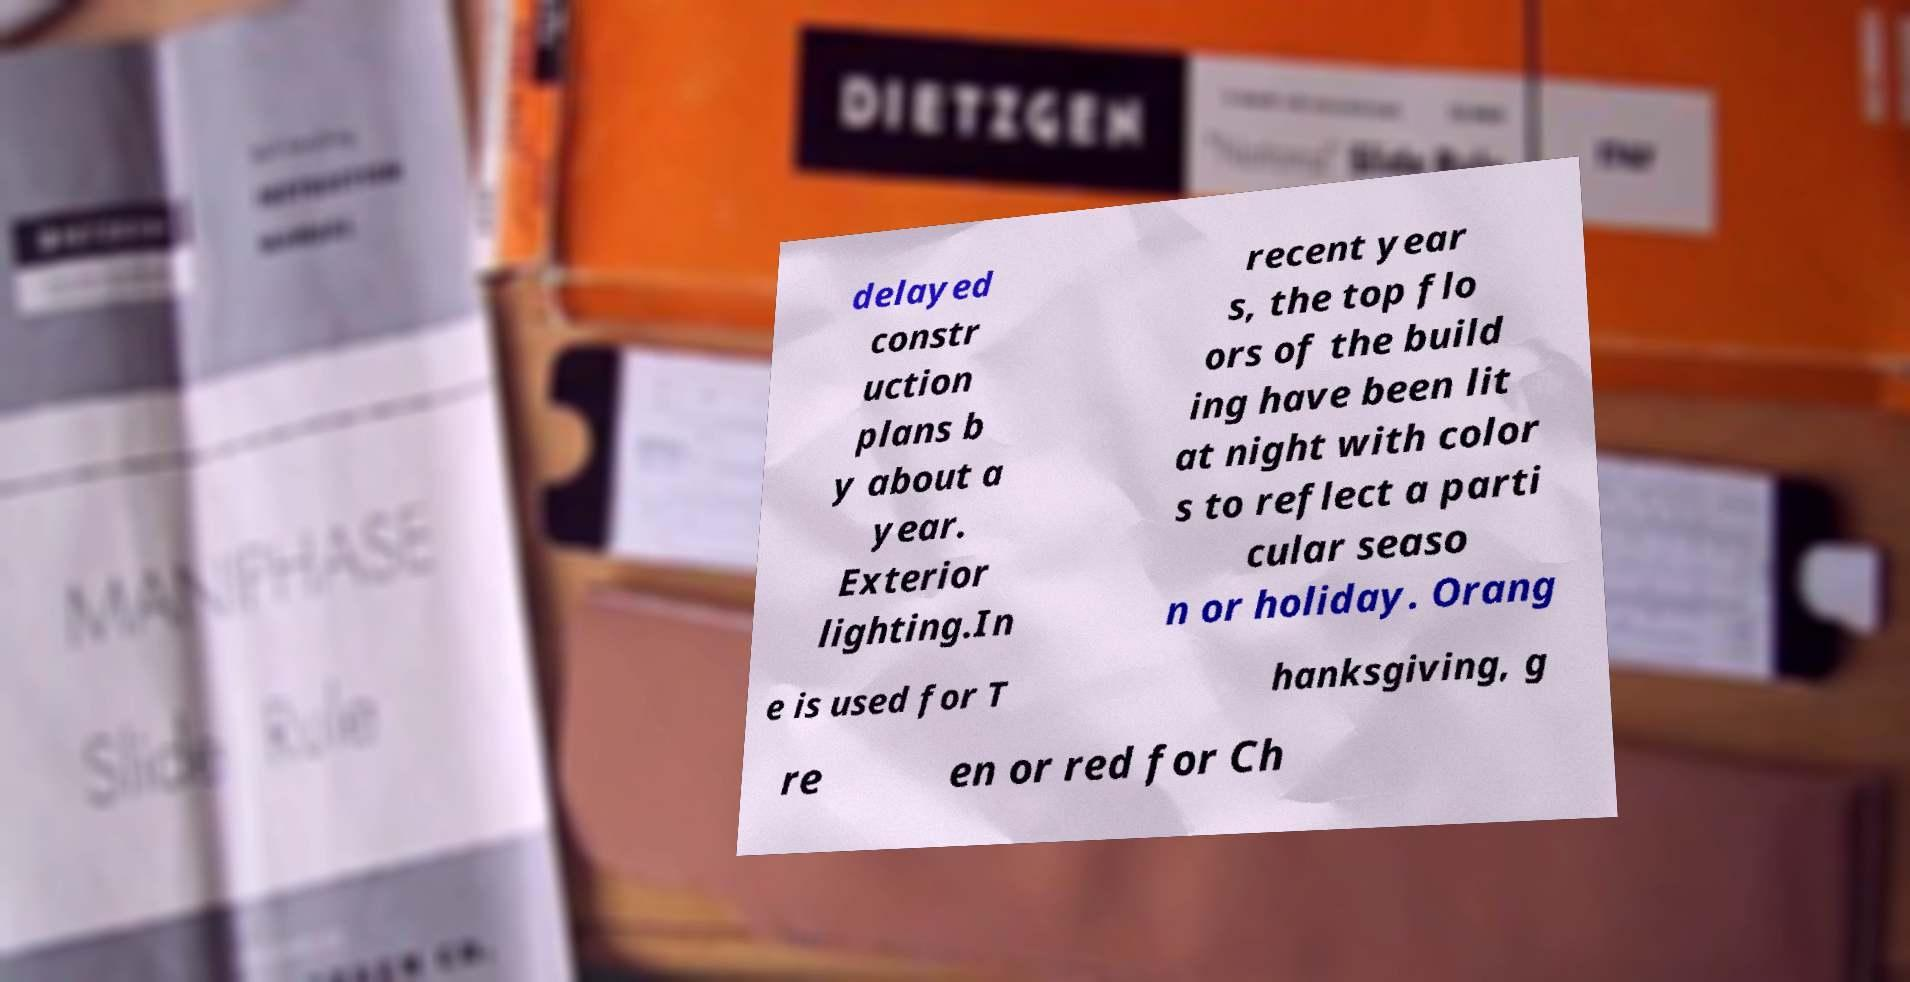Can you accurately transcribe the text from the provided image for me? delayed constr uction plans b y about a year. Exterior lighting.In recent year s, the top flo ors of the build ing have been lit at night with color s to reflect a parti cular seaso n or holiday. Orang e is used for T hanksgiving, g re en or red for Ch 